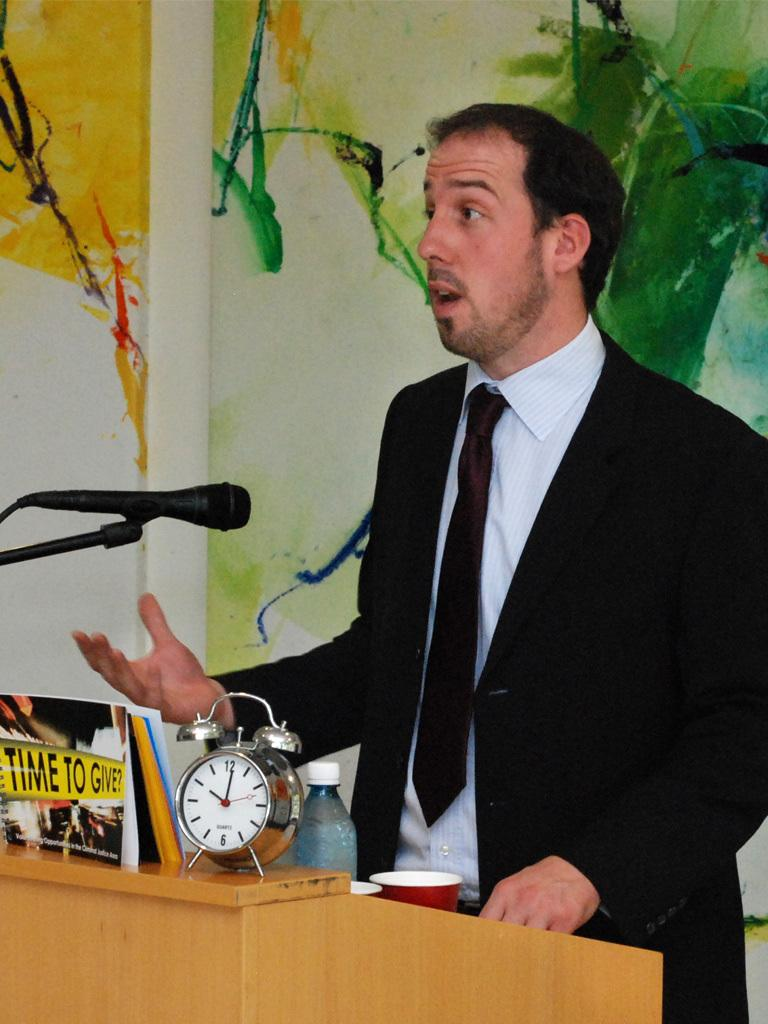Provide a one-sentence caption for the provided image. A man standing at a podium with a clock and a Time to Give picture. 